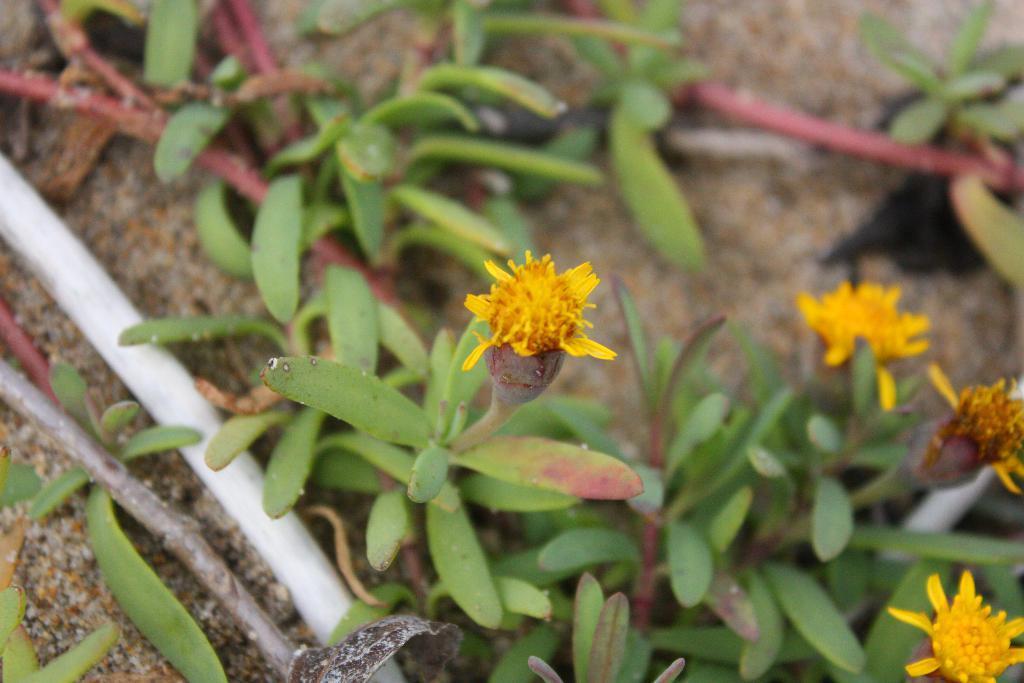In one or two sentences, can you explain what this image depicts? In this image I can see few flowers in yellow color, background I can see plants in green color and I can also see few pipes. 